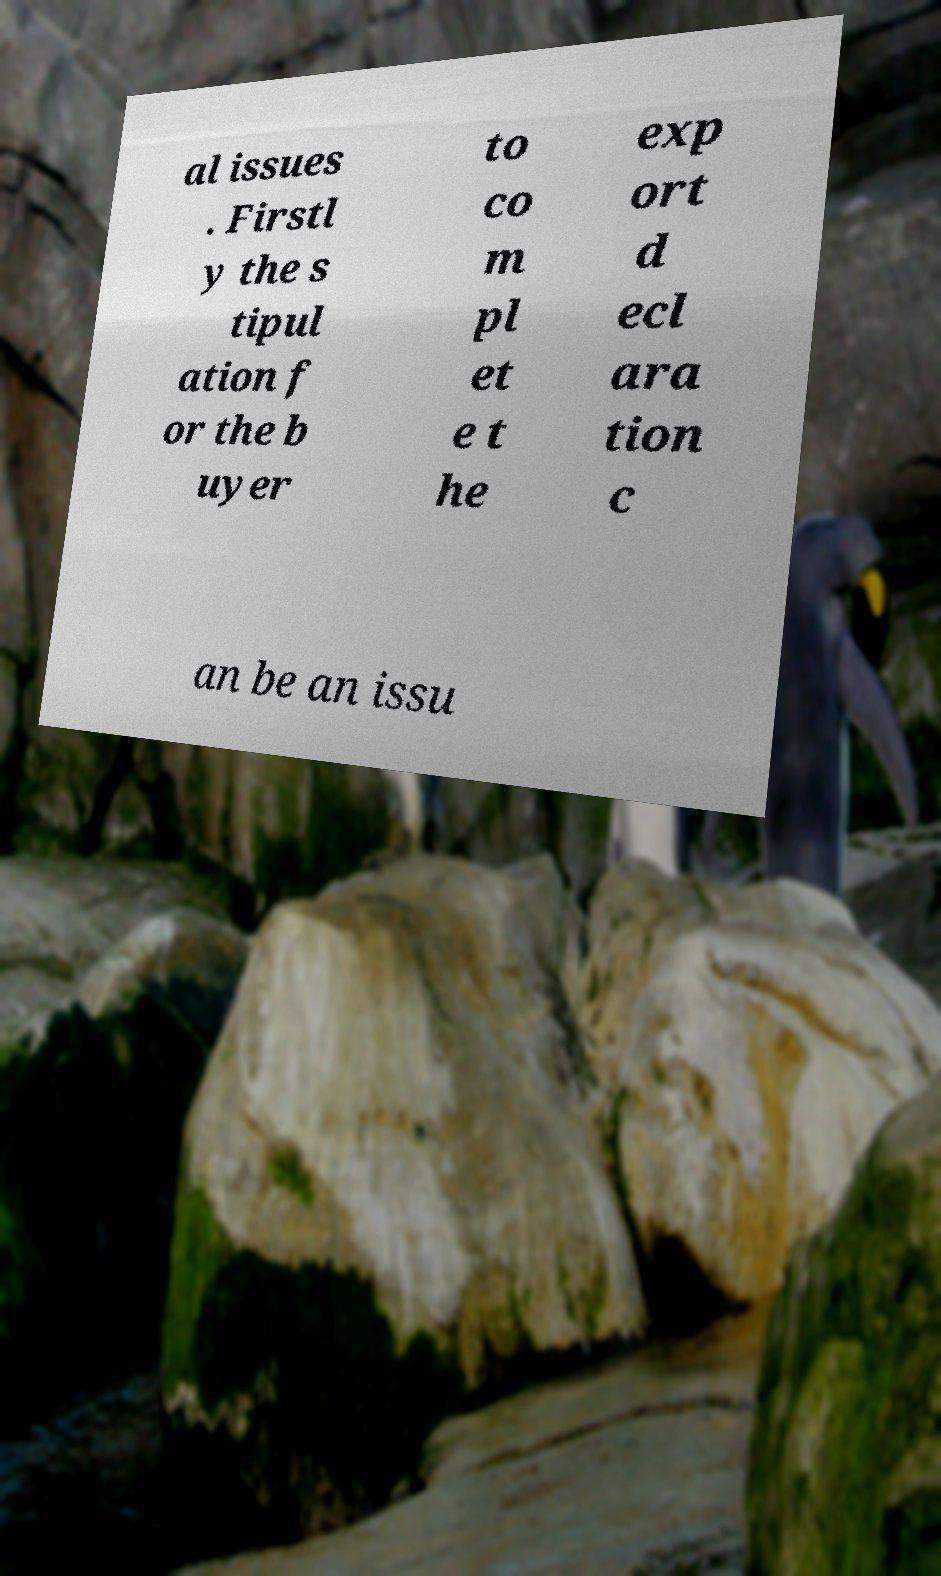Could you extract and type out the text from this image? al issues . Firstl y the s tipul ation f or the b uyer to co m pl et e t he exp ort d ecl ara tion c an be an issu 